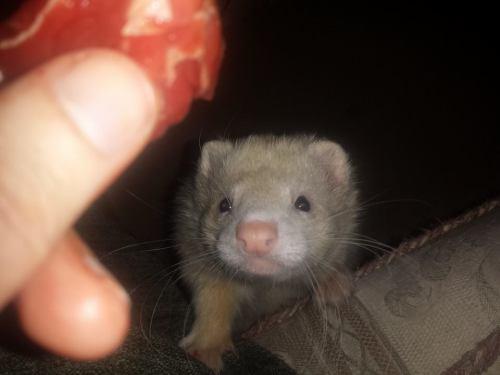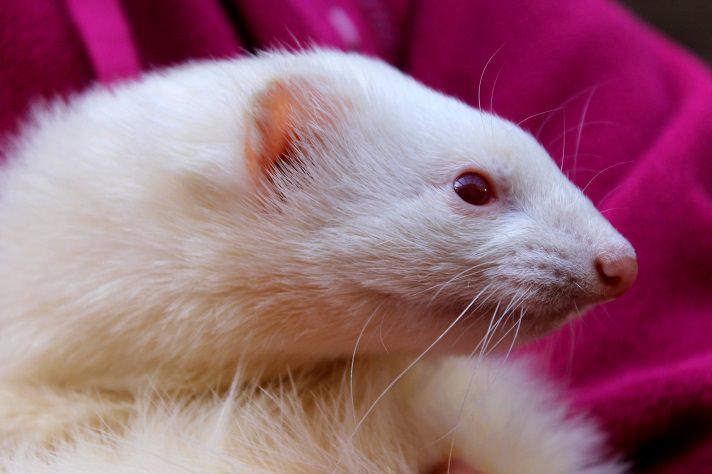The first image is the image on the left, the second image is the image on the right. For the images shown, is this caption "Someone is offering a ferret a piece of raw meat in at least one image." true? Answer yes or no. Yes. The first image is the image on the left, the second image is the image on the right. Evaluate the accuracy of this statement regarding the images: "The left and right image contains the same number of ferrits with at least one person hand in one image.". Is it true? Answer yes or no. Yes. 